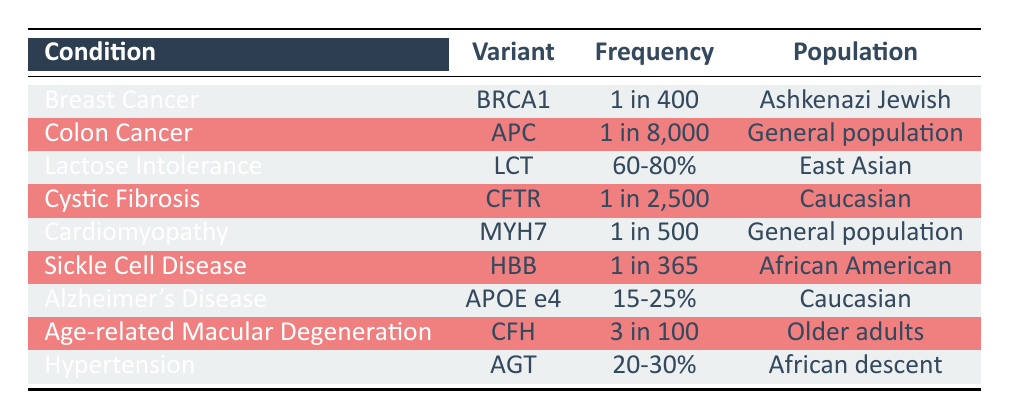What is the frequency of the BRCA1 variant associated with Breast Cancer? The table indicates that the frequency of the BRCA1 variant, which is associated with Breast Cancer, is "1 in 400."
Answer: 1 in 400 Which population has the highest frequency for Lactose Intolerance? The table shows that the LCT variant for Lactose Intolerance has a frequency of "60-80%" specifically in the East Asian population, which is the highest compared to other conditions listed.
Answer: East Asian True or False: The frequency of Cardiomyopathy is 1 in 200. By checking the table, the frequency of the MYH7 variant for Cardiomyopathy is listed as "1 in 500," thus the statement is false.
Answer: False What is the frequency range of Alzheimer's Disease associated with the APOE e4 variant? The frequency range of the APOE e4 variant for Alzheimer's Disease, as per the table, is "15-25%." This is a specific range provided for this condition.
Answer: 15-25% Sum the frequencies for Hypertension and Lactose Intolerance and describe the result. The frequency for Hypertension (AGT) is "20-30%" and for Lactose Intolerance (LCT) is "60-80%." Since these are ranges, it is not straightforward to add them directly. If we consider the midpoints, we might estimate 25% for Hypertension and 70% for Lactose Intolerance, giving a rough sum of 95%. The actual summation can vary depending on actual frequencies.
Answer: 95% (approximate) How many conditions listed have a frequency of 1 in 365 or lower? Looking through the table, we count the variants: BRCA1 (1 in 400), Sickle Cell Disease (1 in 365), Cystic Fibrosis (1 in 2500), and MYH7 Cardiomyopathy (1 in 500). So, the conditions are Breast Cancer (1 in 400), Sickle Cell Disease (1 in 365), and Cardiomyopathy (1 in 500). Therefore, there are three conditions listed with frequencies of 1 in 365 or lower.
Answer: 3 What percentage range of the population of African descent has Hypertension? The table specifies that the AGT variant for Hypertension has a frequency range of "20-30%" among the population of African descent, indicating that a significant portion of this demographic is affected.
Answer: 20-30% Which condition has a lower frequency, Colon Cancer or Cystic Fibrosis? The table states that Colon Cancer has a frequency of "1 in 8,000" and Cystic Fibrosis has a frequency of "1 in 2,500." Comparing these two, since 1 in 8,000 is less frequent than 1 in 2,500, this means Colon Cancer has a lower frequency.
Answer: Colon Cancer 